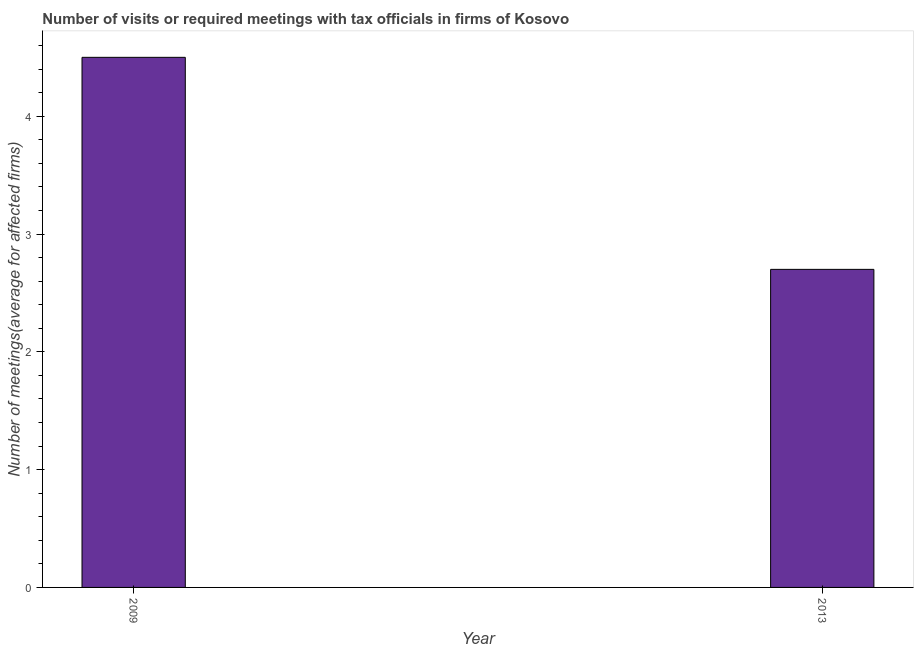What is the title of the graph?
Your answer should be compact. Number of visits or required meetings with tax officials in firms of Kosovo. What is the label or title of the Y-axis?
Offer a terse response. Number of meetings(average for affected firms). What is the number of required meetings with tax officials in 2009?
Provide a short and direct response. 4.5. Across all years, what is the maximum number of required meetings with tax officials?
Your response must be concise. 4.5. In which year was the number of required meetings with tax officials minimum?
Keep it short and to the point. 2013. What is the sum of the number of required meetings with tax officials?
Offer a terse response. 7.2. What is the difference between the number of required meetings with tax officials in 2009 and 2013?
Your answer should be very brief. 1.8. What is the median number of required meetings with tax officials?
Your response must be concise. 3.6. Do a majority of the years between 2009 and 2013 (inclusive) have number of required meetings with tax officials greater than 1.8 ?
Offer a terse response. Yes. What is the ratio of the number of required meetings with tax officials in 2009 to that in 2013?
Keep it short and to the point. 1.67. Is the number of required meetings with tax officials in 2009 less than that in 2013?
Offer a very short reply. No. Are all the bars in the graph horizontal?
Provide a succinct answer. No. How many years are there in the graph?
Give a very brief answer. 2. What is the difference between two consecutive major ticks on the Y-axis?
Your response must be concise. 1. What is the Number of meetings(average for affected firms) in 2013?
Your answer should be very brief. 2.7. What is the ratio of the Number of meetings(average for affected firms) in 2009 to that in 2013?
Give a very brief answer. 1.67. 